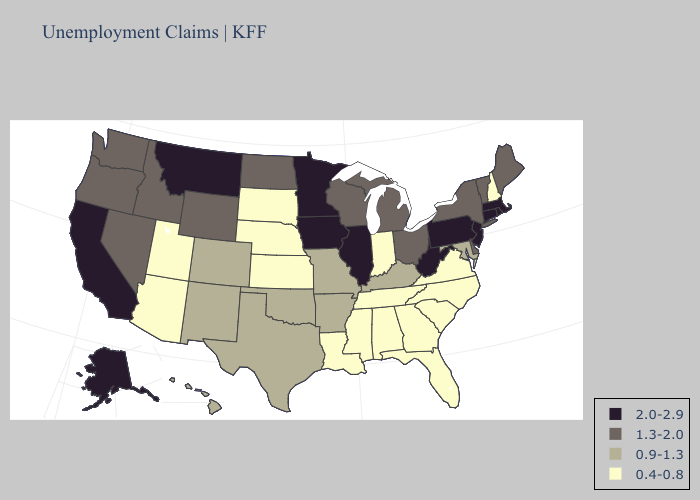Does South Dakota have the lowest value in the MidWest?
Concise answer only. Yes. Name the states that have a value in the range 2.0-2.9?
Answer briefly. Alaska, California, Connecticut, Illinois, Iowa, Massachusetts, Minnesota, Montana, New Jersey, Pennsylvania, Rhode Island, West Virginia. Name the states that have a value in the range 1.3-2.0?
Short answer required. Delaware, Idaho, Maine, Michigan, Nevada, New York, North Dakota, Ohio, Oregon, Vermont, Washington, Wisconsin, Wyoming. Does Kentucky have the lowest value in the South?
Short answer required. No. Which states have the highest value in the USA?
Quick response, please. Alaska, California, Connecticut, Illinois, Iowa, Massachusetts, Minnesota, Montana, New Jersey, Pennsylvania, Rhode Island, West Virginia. Does California have the highest value in the USA?
Write a very short answer. Yes. Is the legend a continuous bar?
Quick response, please. No. What is the highest value in the West ?
Quick response, please. 2.0-2.9. What is the highest value in states that border Nebraska?
Write a very short answer. 2.0-2.9. Is the legend a continuous bar?
Concise answer only. No. What is the value of Oregon?
Short answer required. 1.3-2.0. What is the value of Nevada?
Short answer required. 1.3-2.0. What is the value of North Carolina?
Concise answer only. 0.4-0.8. What is the value of Oregon?
Keep it brief. 1.3-2.0. What is the highest value in the USA?
Keep it brief. 2.0-2.9. 